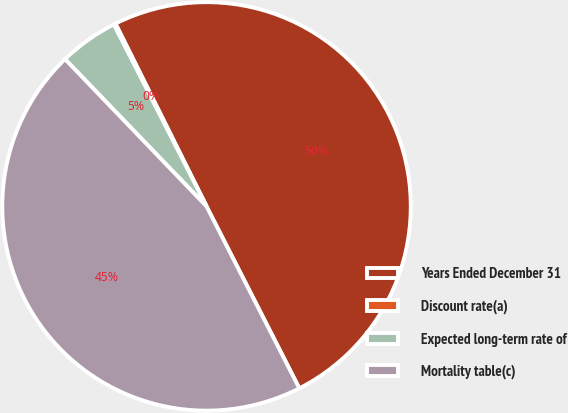<chart> <loc_0><loc_0><loc_500><loc_500><pie_chart><fcel>Years Ended December 31<fcel>Discount rate(a)<fcel>Expected long-term rate of<fcel>Mortality table(c)<nl><fcel>49.85%<fcel>0.15%<fcel>4.68%<fcel>45.32%<nl></chart> 